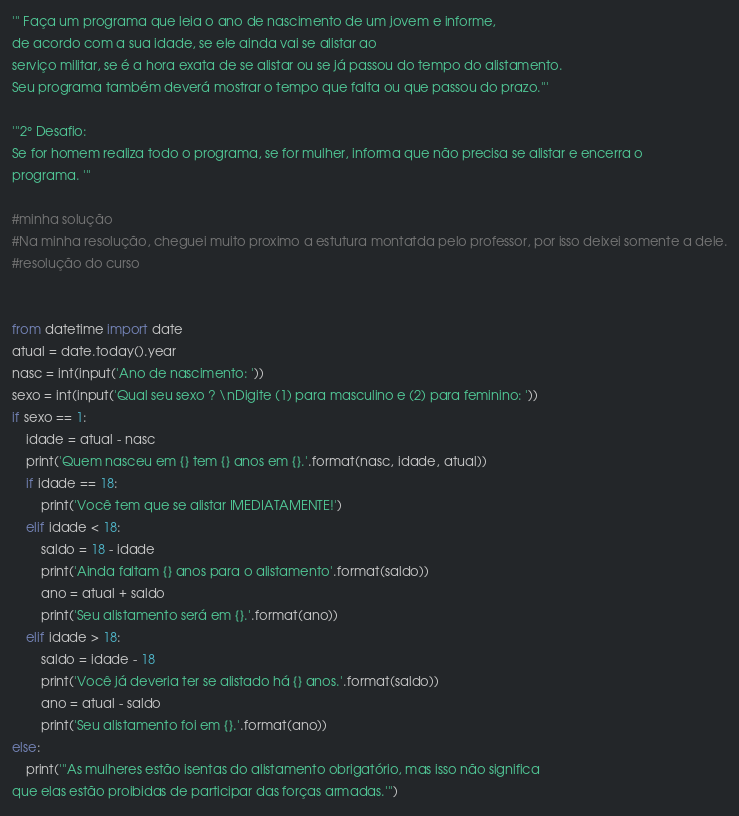<code> <loc_0><loc_0><loc_500><loc_500><_Python_>''' Faça um programa que leia o ano de nascimento de um jovem e informe,
de acordo com a sua idade, se ele ainda vai se alistar ao
serviço militar, se é a hora exata de se alistar ou se já passou do tempo do alistamento.
Seu programa também deverá mostrar o tempo que falta ou que passou do prazo.'''

'''2° Desafio:
Se for homem realiza todo o programa, se for mulher, informa que não precisa se alistar e encerra o 
programa. '''

#minha solução
#Na minha resolução, cheguei muito proximo a estutura montatda pelo professor, por isso deixei somente a dele.
#resolução do curso


from datetime import date
atual = date.today().year
nasc = int(input('Ano de nascimento: '))
sexo = int(input('Qual seu sexo ? \nDigite (1) para masculino e (2) para feminino: '))
if sexo == 1:
    idade = atual - nasc
    print('Quem nasceu em {} tem {} anos em {}.'.format(nasc, idade, atual))
    if idade == 18:
        print('Você tem que se alistar IMEDIATAMENTE!')
    elif idade < 18:
        saldo = 18 - idade
        print('Ainda faltam {} anos para o alistamento'.format(saldo))
        ano = atual + saldo
        print('Seu alistamento será em {}.'.format(ano))
    elif idade > 18:
        saldo = idade - 18
        print('Você já deveria ter se alistado há {} anos.'.format(saldo))
        ano = atual - saldo
        print('Seu alistamento foi em {}.'.format(ano))
else:
    print('''As mulheres estão isentas do alistamento obrigatório, mas isso não significa 
que elas estão proibidas de participar das forças armadas.''')</code> 